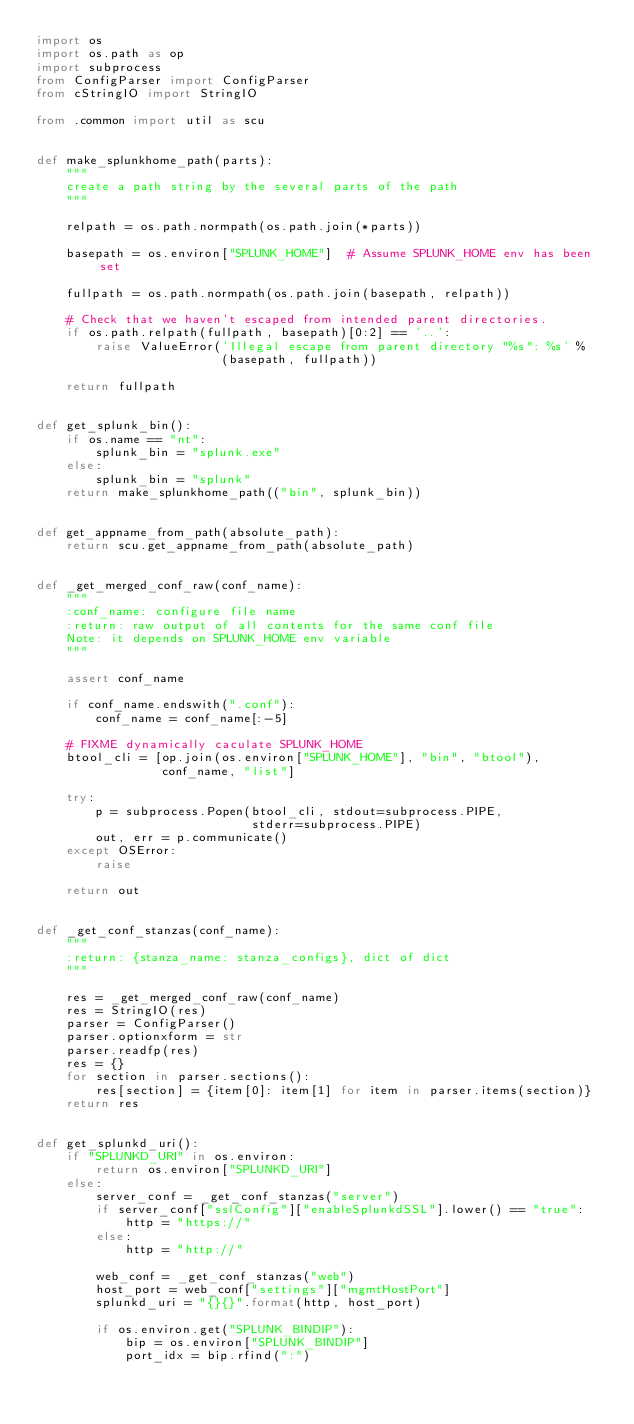<code> <loc_0><loc_0><loc_500><loc_500><_Python_>import os
import os.path as op
import subprocess
from ConfigParser import ConfigParser
from cStringIO import StringIO

from .common import util as scu


def make_splunkhome_path(parts):
    """
    create a path string by the several parts of the path
    """

    relpath = os.path.normpath(os.path.join(*parts))

    basepath = os.environ["SPLUNK_HOME"]  # Assume SPLUNK_HOME env has been set

    fullpath = os.path.normpath(os.path.join(basepath, relpath))

    # Check that we haven't escaped from intended parent directories.
    if os.path.relpath(fullpath, basepath)[0:2] == '..':
        raise ValueError('Illegal escape from parent directory "%s": %s' %
                         (basepath, fullpath))

    return fullpath


def get_splunk_bin():
    if os.name == "nt":
        splunk_bin = "splunk.exe"
    else:
        splunk_bin = "splunk"
    return make_splunkhome_path(("bin", splunk_bin))


def get_appname_from_path(absolute_path):
    return scu.get_appname_from_path(absolute_path)


def _get_merged_conf_raw(conf_name):
    """
    :conf_name: configure file name
    :return: raw output of all contents for the same conf file
    Note: it depends on SPLUNK_HOME env variable
    """

    assert conf_name

    if conf_name.endswith(".conf"):
        conf_name = conf_name[:-5]

    # FIXME dynamically caculate SPLUNK_HOME
    btool_cli = [op.join(os.environ["SPLUNK_HOME"], "bin", "btool"),
                 conf_name, "list"]

    try:
        p = subprocess.Popen(btool_cli, stdout=subprocess.PIPE,
                             stderr=subprocess.PIPE)
        out, err = p.communicate()
    except OSError:
        raise

    return out


def _get_conf_stanzas(conf_name):
    """
    :return: {stanza_name: stanza_configs}, dict of dict
    """

    res = _get_merged_conf_raw(conf_name)
    res = StringIO(res)
    parser = ConfigParser()
    parser.optionxform = str
    parser.readfp(res)
    res = {}
    for section in parser.sections():
        res[section] = {item[0]: item[1] for item in parser.items(section)}
    return res


def get_splunkd_uri():
    if "SPLUNKD_URI" in os.environ:
        return os.environ["SPLUNKD_URI"]
    else:
        server_conf = _get_conf_stanzas("server")
        if server_conf["sslConfig"]["enableSplunkdSSL"].lower() == "true":
            http = "https://"
        else:
            http = "http://"

        web_conf = _get_conf_stanzas("web")
        host_port = web_conf["settings"]["mgmtHostPort"]
        splunkd_uri = "{}{}".format(http, host_port)

        if os.environ.get("SPLUNK_BINDIP"):
            bip = os.environ["SPLUNK_BINDIP"]
            port_idx = bip.rfind(":")</code> 